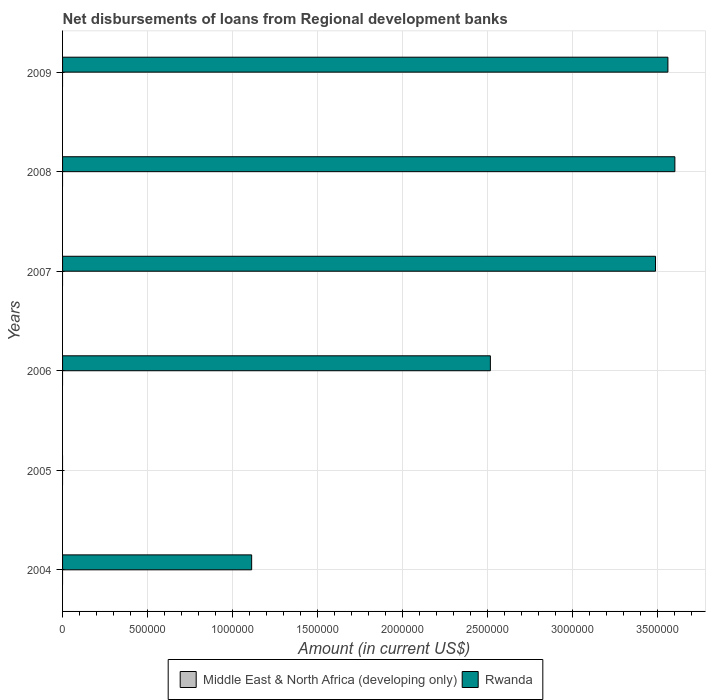How many different coloured bars are there?
Give a very brief answer. 1. Are the number of bars on each tick of the Y-axis equal?
Keep it short and to the point. No. How many bars are there on the 5th tick from the top?
Keep it short and to the point. 0. How many bars are there on the 5th tick from the bottom?
Offer a very short reply. 1. What is the amount of disbursements of loans from regional development banks in Rwanda in 2005?
Provide a short and direct response. 0. Across all years, what is the maximum amount of disbursements of loans from regional development banks in Rwanda?
Your response must be concise. 3.60e+06. Across all years, what is the minimum amount of disbursements of loans from regional development banks in Middle East & North Africa (developing only)?
Your answer should be very brief. 0. What is the total amount of disbursements of loans from regional development banks in Rwanda in the graph?
Keep it short and to the point. 1.43e+07. What is the difference between the amount of disbursements of loans from regional development banks in Rwanda in 2007 and that in 2009?
Give a very brief answer. -7.30e+04. What is the difference between the amount of disbursements of loans from regional development banks in Middle East & North Africa (developing only) in 2004 and the amount of disbursements of loans from regional development banks in Rwanda in 2007?
Ensure brevity in your answer.  -3.49e+06. What is the average amount of disbursements of loans from regional development banks in Middle East & North Africa (developing only) per year?
Give a very brief answer. 0. In how many years, is the amount of disbursements of loans from regional development banks in Rwanda greater than 500000 US$?
Provide a succinct answer. 5. What is the ratio of the amount of disbursements of loans from regional development banks in Rwanda in 2007 to that in 2009?
Your response must be concise. 0.98. What is the difference between the highest and the second highest amount of disbursements of loans from regional development banks in Rwanda?
Keep it short and to the point. 4.10e+04. What is the difference between the highest and the lowest amount of disbursements of loans from regional development banks in Rwanda?
Provide a succinct answer. 3.60e+06. How many bars are there?
Your answer should be very brief. 5. Does the graph contain grids?
Offer a terse response. Yes. Where does the legend appear in the graph?
Offer a very short reply. Bottom center. How many legend labels are there?
Offer a terse response. 2. How are the legend labels stacked?
Offer a terse response. Horizontal. What is the title of the graph?
Provide a short and direct response. Net disbursements of loans from Regional development banks. Does "Jordan" appear as one of the legend labels in the graph?
Your answer should be very brief. No. What is the label or title of the X-axis?
Ensure brevity in your answer.  Amount (in current US$). What is the Amount (in current US$) of Rwanda in 2004?
Your answer should be very brief. 1.11e+06. What is the Amount (in current US$) in Rwanda in 2005?
Ensure brevity in your answer.  0. What is the Amount (in current US$) of Rwanda in 2006?
Give a very brief answer. 2.52e+06. What is the Amount (in current US$) of Rwanda in 2007?
Offer a terse response. 3.49e+06. What is the Amount (in current US$) of Middle East & North Africa (developing only) in 2008?
Keep it short and to the point. 0. What is the Amount (in current US$) of Rwanda in 2008?
Provide a succinct answer. 3.60e+06. What is the Amount (in current US$) in Rwanda in 2009?
Keep it short and to the point. 3.56e+06. Across all years, what is the maximum Amount (in current US$) in Rwanda?
Give a very brief answer. 3.60e+06. What is the total Amount (in current US$) in Middle East & North Africa (developing only) in the graph?
Your answer should be very brief. 0. What is the total Amount (in current US$) in Rwanda in the graph?
Your answer should be very brief. 1.43e+07. What is the difference between the Amount (in current US$) in Rwanda in 2004 and that in 2006?
Ensure brevity in your answer.  -1.40e+06. What is the difference between the Amount (in current US$) in Rwanda in 2004 and that in 2007?
Make the answer very short. -2.38e+06. What is the difference between the Amount (in current US$) of Rwanda in 2004 and that in 2008?
Ensure brevity in your answer.  -2.49e+06. What is the difference between the Amount (in current US$) of Rwanda in 2004 and that in 2009?
Give a very brief answer. -2.45e+06. What is the difference between the Amount (in current US$) of Rwanda in 2006 and that in 2007?
Make the answer very short. -9.72e+05. What is the difference between the Amount (in current US$) in Rwanda in 2006 and that in 2008?
Provide a short and direct response. -1.09e+06. What is the difference between the Amount (in current US$) in Rwanda in 2006 and that in 2009?
Provide a short and direct response. -1.04e+06. What is the difference between the Amount (in current US$) of Rwanda in 2007 and that in 2008?
Provide a short and direct response. -1.14e+05. What is the difference between the Amount (in current US$) in Rwanda in 2007 and that in 2009?
Keep it short and to the point. -7.30e+04. What is the difference between the Amount (in current US$) in Rwanda in 2008 and that in 2009?
Your answer should be very brief. 4.10e+04. What is the average Amount (in current US$) of Middle East & North Africa (developing only) per year?
Provide a short and direct response. 0. What is the average Amount (in current US$) of Rwanda per year?
Your answer should be very brief. 2.38e+06. What is the ratio of the Amount (in current US$) in Rwanda in 2004 to that in 2006?
Make the answer very short. 0.44. What is the ratio of the Amount (in current US$) of Rwanda in 2004 to that in 2007?
Make the answer very short. 0.32. What is the ratio of the Amount (in current US$) in Rwanda in 2004 to that in 2008?
Make the answer very short. 0.31. What is the ratio of the Amount (in current US$) of Rwanda in 2004 to that in 2009?
Your response must be concise. 0.31. What is the ratio of the Amount (in current US$) in Rwanda in 2006 to that in 2007?
Your response must be concise. 0.72. What is the ratio of the Amount (in current US$) of Rwanda in 2006 to that in 2008?
Provide a short and direct response. 0.7. What is the ratio of the Amount (in current US$) of Rwanda in 2006 to that in 2009?
Provide a succinct answer. 0.71. What is the ratio of the Amount (in current US$) in Rwanda in 2007 to that in 2008?
Make the answer very short. 0.97. What is the ratio of the Amount (in current US$) in Rwanda in 2007 to that in 2009?
Your answer should be compact. 0.98. What is the ratio of the Amount (in current US$) in Rwanda in 2008 to that in 2009?
Your response must be concise. 1.01. What is the difference between the highest and the second highest Amount (in current US$) of Rwanda?
Provide a succinct answer. 4.10e+04. What is the difference between the highest and the lowest Amount (in current US$) of Rwanda?
Provide a succinct answer. 3.60e+06. 